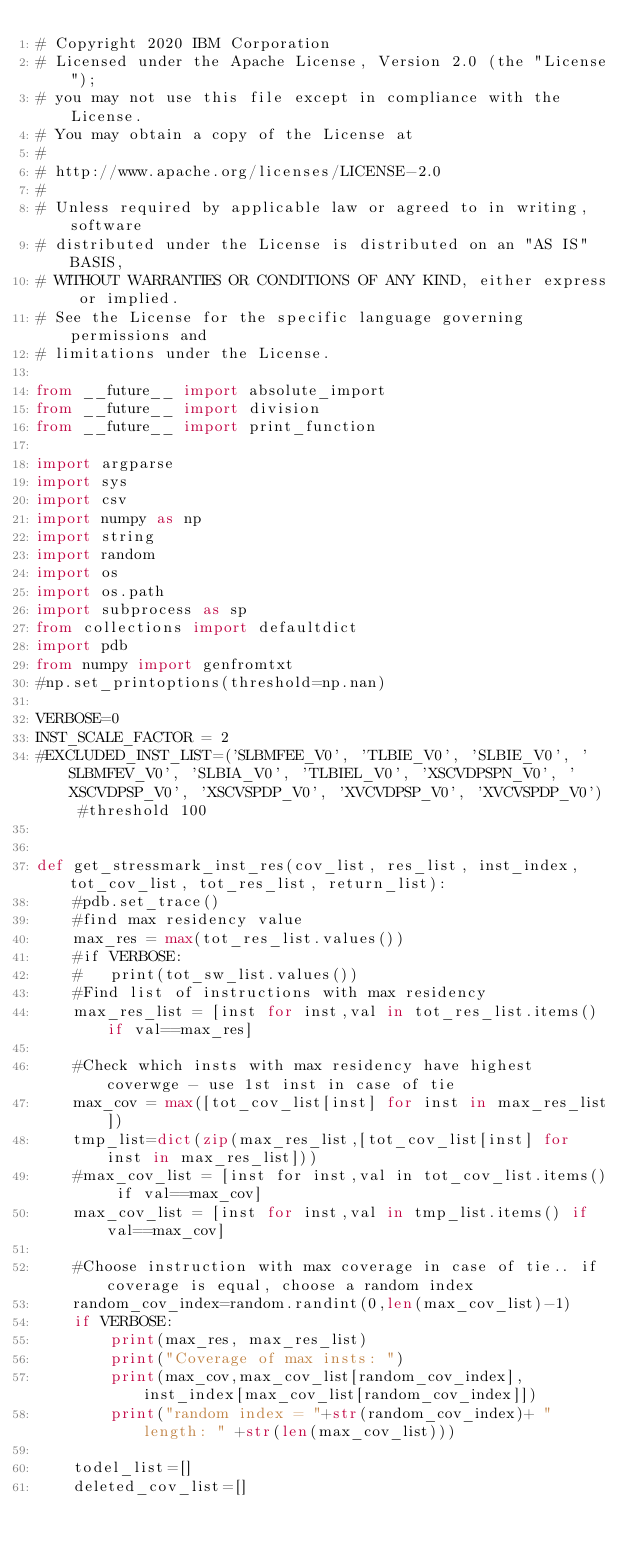Convert code to text. <code><loc_0><loc_0><loc_500><loc_500><_Python_># Copyright 2020 IBM Corporation
# Licensed under the Apache License, Version 2.0 (the "License");
# you may not use this file except in compliance with the License.
# You may obtain a copy of the License at
#
# http://www.apache.org/licenses/LICENSE-2.0
#
# Unless required by applicable law or agreed to in writing, software
# distributed under the License is distributed on an "AS IS" BASIS,
# WITHOUT WARRANTIES OR CONDITIONS OF ANY KIND, either express or implied.
# See the License for the specific language governing permissions and
# limitations under the License.

from __future__ import absolute_import
from __future__ import division
from __future__ import print_function

import argparse
import sys
import csv
import numpy as np
import string
import random
import os
import os.path
import subprocess as sp
from collections import defaultdict
import pdb 
from numpy import genfromtxt
#np.set_printoptions(threshold=np.nan)

VERBOSE=0
INST_SCALE_FACTOR = 2
#EXCLUDED_INST_LIST=('SLBMFEE_V0', 'TLBIE_V0', 'SLBIE_V0', 'SLBMFEV_V0', 'SLBIA_V0', 'TLBIEL_V0', 'XSCVDPSPN_V0', 'XSCVDPSP_V0', 'XSCVSPDP_V0', 'XVCVDPSP_V0', 'XVCVSPDP_V0') #threshold 100


def get_stressmark_inst_res(cov_list, res_list, inst_index, tot_cov_list, tot_res_list, return_list):
    #pdb.set_trace()
    #find max residency value
    max_res = max(tot_res_list.values())
    #if VERBOSE:
    #	print(tot_sw_list.values())
    #Find list of instructions with max residency
    max_res_list = [inst for inst,val in tot_res_list.items() if val==max_res]

    #Check which insts with max residency have highest coverwge - use 1st inst in case of tie
    max_cov = max([tot_cov_list[inst] for inst in max_res_list])
    tmp_list=dict(zip(max_res_list,[tot_cov_list[inst] for inst in max_res_list]))
    #max_cov_list = [inst for inst,val in tot_cov_list.items() if val==max_cov]
    max_cov_list = [inst for inst,val in tmp_list.items() if val==max_cov]

    #Choose instruction with max coverage in case of tie.. if coverage is equal, choose a random index
    random_cov_index=random.randint(0,len(max_cov_list)-1)  
    if VERBOSE: 
        print(max_res, max_res_list)
        print("Coverage of max insts: ")
        print(max_cov,max_cov_list[random_cov_index],inst_index[max_cov_list[random_cov_index]])
        print("random index = "+str(random_cov_index)+ " length: " +str(len(max_cov_list)))
    
    todel_list=[]
    deleted_cov_list=[]</code> 